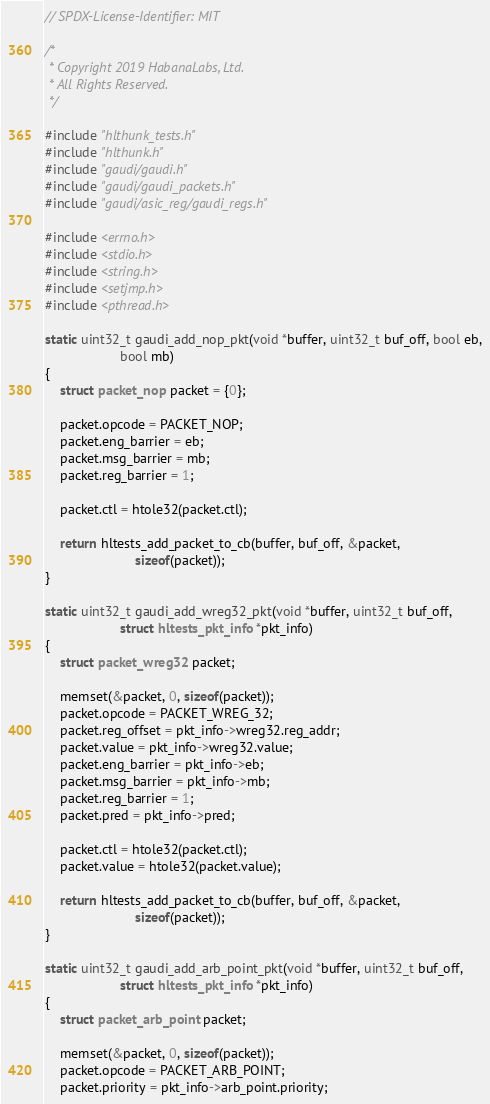Convert code to text. <code><loc_0><loc_0><loc_500><loc_500><_C_>// SPDX-License-Identifier: MIT

/*
 * Copyright 2019 HabanaLabs, Ltd.
 * All Rights Reserved.
 */

#include "hlthunk_tests.h"
#include "hlthunk.h"
#include "gaudi/gaudi.h"
#include "gaudi/gaudi_packets.h"
#include "gaudi/asic_reg/gaudi_regs.h"

#include <errno.h>
#include <stdio.h>
#include <string.h>
#include <setjmp.h>
#include <pthread.h>

static uint32_t gaudi_add_nop_pkt(void *buffer, uint32_t buf_off, bool eb,
					bool mb)
{
	struct packet_nop packet = {0};

	packet.opcode = PACKET_NOP;
	packet.eng_barrier = eb;
	packet.msg_barrier = mb;
	packet.reg_barrier = 1;

	packet.ctl = htole32(packet.ctl);

	return hltests_add_packet_to_cb(buffer, buf_off, &packet,
						sizeof(packet));
}

static uint32_t gaudi_add_wreg32_pkt(void *buffer, uint32_t buf_off,
					struct hltests_pkt_info *pkt_info)
{
	struct packet_wreg32 packet;

	memset(&packet, 0, sizeof(packet));
	packet.opcode = PACKET_WREG_32;
	packet.reg_offset = pkt_info->wreg32.reg_addr;
	packet.value = pkt_info->wreg32.value;
	packet.eng_barrier = pkt_info->eb;
	packet.msg_barrier = pkt_info->mb;
	packet.reg_barrier = 1;
	packet.pred = pkt_info->pred;

	packet.ctl = htole32(packet.ctl);
	packet.value = htole32(packet.value);

	return hltests_add_packet_to_cb(buffer, buf_off, &packet,
						sizeof(packet));
}

static uint32_t gaudi_add_arb_point_pkt(void *buffer, uint32_t buf_off,
					struct hltests_pkt_info *pkt_info)
{
	struct packet_arb_point packet;

	memset(&packet, 0, sizeof(packet));
	packet.opcode = PACKET_ARB_POINT;
	packet.priority = pkt_info->arb_point.priority;</code> 